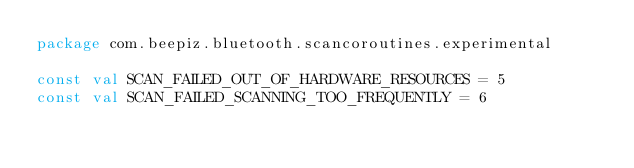<code> <loc_0><loc_0><loc_500><loc_500><_Kotlin_>package com.beepiz.bluetooth.scancoroutines.experimental

const val SCAN_FAILED_OUT_OF_HARDWARE_RESOURCES = 5
const val SCAN_FAILED_SCANNING_TOO_FREQUENTLY = 6
</code> 